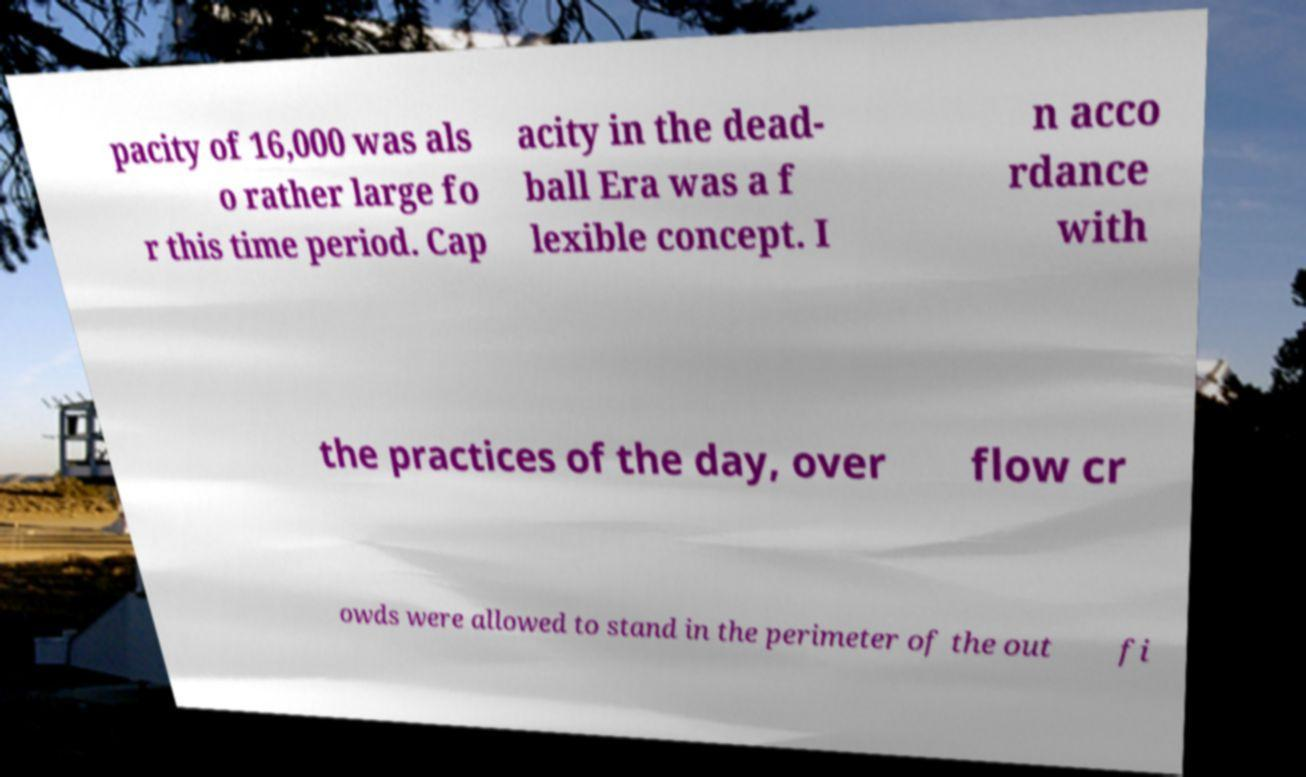There's text embedded in this image that I need extracted. Can you transcribe it verbatim? pacity of 16,000 was als o rather large fo r this time period. Cap acity in the dead- ball Era was a f lexible concept. I n acco rdance with the practices of the day, over flow cr owds were allowed to stand in the perimeter of the out fi 